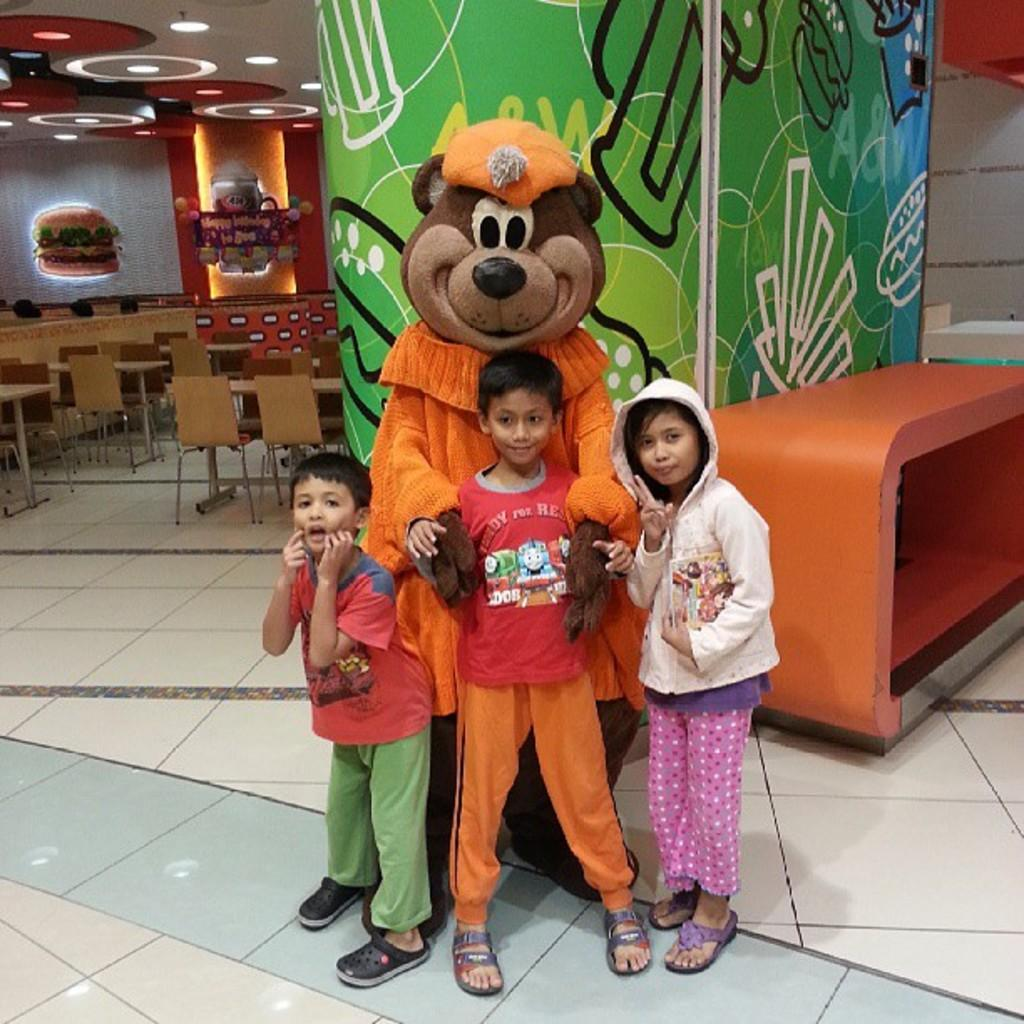Who is present in the image? There are children in the image. What toy can be seen with the children? There is a teddy bear in the image. What type of furniture is visible in the background? There are chairs and tables in the background of the image. What can be seen on the ceiling in the background? There are lights on the ceiling in the background of the image. What type of snail is crawling on the teddy bear in the image? There is no snail present in the image; it only features children, a teddy bear, chairs, tables, and lights on the ceiling. 